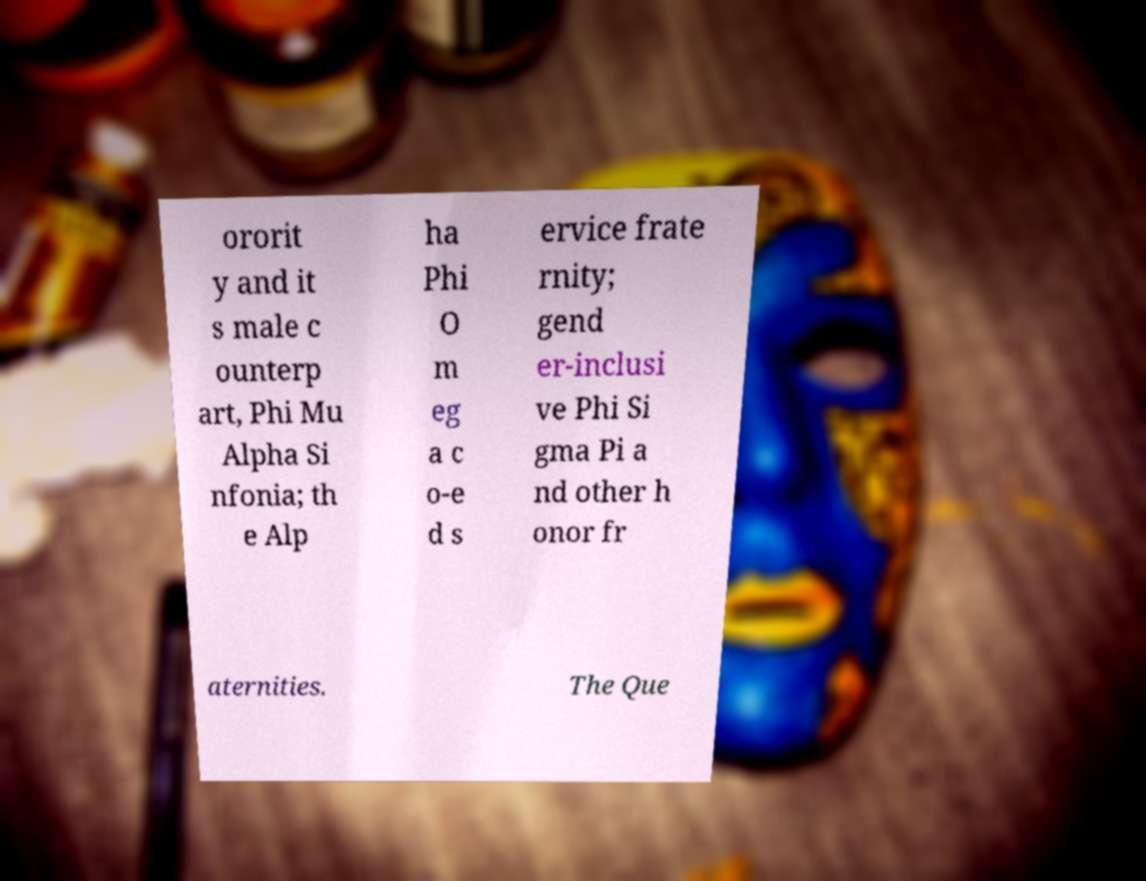What messages or text are displayed in this image? I need them in a readable, typed format. ororit y and it s male c ounterp art, Phi Mu Alpha Si nfonia; th e Alp ha Phi O m eg a c o-e d s ervice frate rnity; gend er-inclusi ve Phi Si gma Pi a nd other h onor fr aternities. The Que 